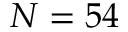<formula> <loc_0><loc_0><loc_500><loc_500>N = 5 4</formula> 